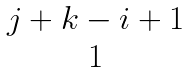Convert formula to latex. <formula><loc_0><loc_0><loc_500><loc_500>\begin{matrix} j + k - i + 1 \\ 1 \end{matrix}</formula> 